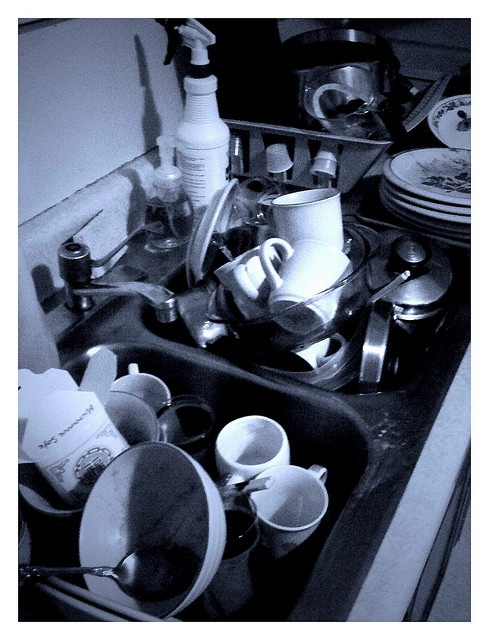Describe the objects in this image and their specific colors. I can see sink in white, black, darkgray, gray, and lavender tones, sink in white, black, and gray tones, bowl in white, black, and darkgray tones, bottle in white, lavender, darkgray, and black tones, and cup in white, black, gray, and darkgray tones in this image. 